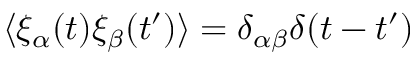<formula> <loc_0><loc_0><loc_500><loc_500>\langle \xi _ { \alpha } ( t ) \xi _ { \beta } ( t ^ { \prime } ) \rangle = \delta _ { \alpha \beta } \delta ( t - t ^ { \prime } )</formula> 